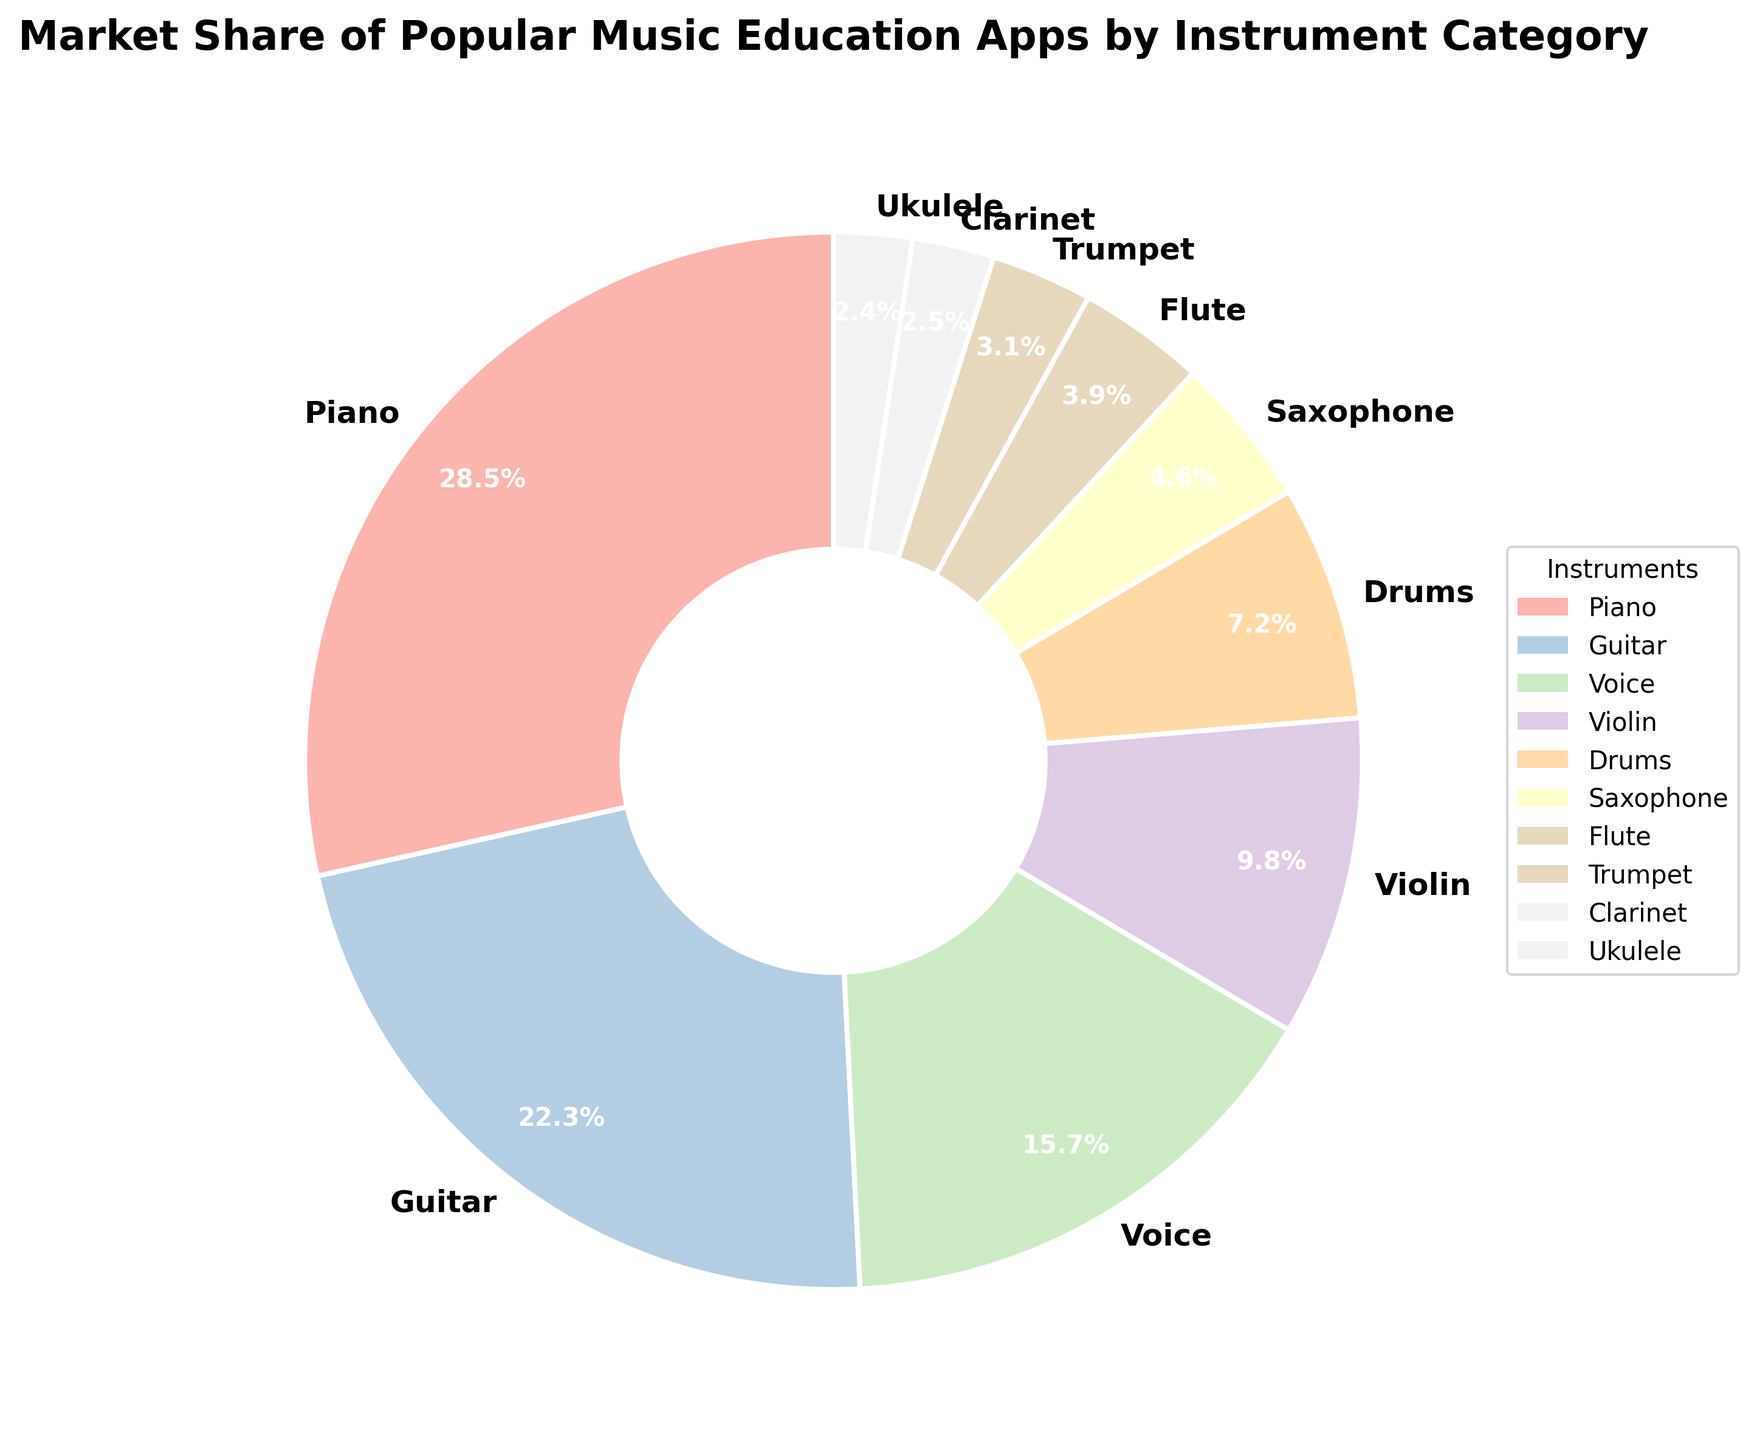What is the instrument category with the highest market share? From the pie chart, the segment with the highest market share is clearly labeled and visually the largest. The label shows Piano with a market share of 28.5%.
Answer: Piano Which instrument category has the smallest market share? By examining the sizes of the pie segments and reading the labels, the smallest segment is Ukulele with a market share of 2.4%.
Answer: Ukulele How much more market share does Piano have compared to Voice? From the chart, Piano has a market share of 28.5% and Voice has 15.7%. Calculating the difference: 28.5% - 15.7% = 12.8%.
Answer: 12.8% What is the total market share of Guitar, Violin, and Ukulele combined? From the pie chart, Guitar has a market share of 22.3%, Violin 9.8%, and Ukulele 2.4%. Adding these together: 22.3% + 9.8% + 2.4% = 34.5%.
Answer: 34.5% Which has a greater market share, Drums or Saxophone? Looking at the pie chart and the size of the segments, Drums has a share of 7.2% and Saxophone has 4.6%. Since 7.2% is greater than 4.6%, Drums has the greater market share.
Answer: Drums What is the combined market share of all instruments with a share less than 5%? Instruments with less than 5% share are Saxophone (4.6%), Flute (3.9%), Trumpet (3.1%), Clarinet (2.5%), and Ukulele (2.4%). Adding these together: 4.6% + 3.9% + 3.1% + 2.5% + 2.4% = 16.5%.
Answer: 16.5% Which instruments together make up more than half the market share? From the pie chart, Piano (28.5%) and Guitar (22.3%) together hold 28.5% + 22.3% = 50.8%, which is more than half the market share.
Answer: Piano and Guitar Comparing Violin and Flute, which one has a larger market share and by how much? In the pie chart, Violin has a market share of 9.8% while Flute has 3.9%. The difference is 9.8% - 3.9% = 5.9%.
Answer: Violin by 5.9% How does the market share of Drums compare with that of Trumpet and Clarinet combined? Drums has a market share of 7.2%. Trumpet has 3.1% and Clarinet has 2.5%, together totaling 3.1% + 2.5% = 5.6%. Since 7.2% is greater than 5.6%, Drums has a higher market share.
Answer: Drums 